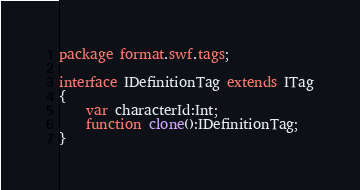<code> <loc_0><loc_0><loc_500><loc_500><_Haxe_>package format.swf.tags;

interface IDefinitionTag extends ITag
{
	var characterId:Int;
	function clone():IDefinitionTag;
}
</code> 